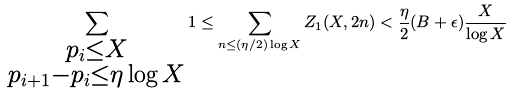<formula> <loc_0><loc_0><loc_500><loc_500>\sum _ { \substack { p _ { i } \leq X \\ p _ { i + 1 } - p _ { i } \leq \eta \log X } } 1 \leq \sum _ { n \leq ( \eta / 2 ) \log X } Z _ { 1 } ( X , 2 n ) < \frac { \eta } { 2 } ( B + \epsilon ) \frac { X } { \log X }</formula> 